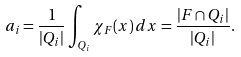Convert formula to latex. <formula><loc_0><loc_0><loc_500><loc_500>a _ { i } = \frac { 1 } { | Q _ { i } | } \int _ { Q _ { i } } \chi _ { F } ( x ) \, d x = \frac { | F \cap Q _ { i } | } { | Q _ { i } | } .</formula> 